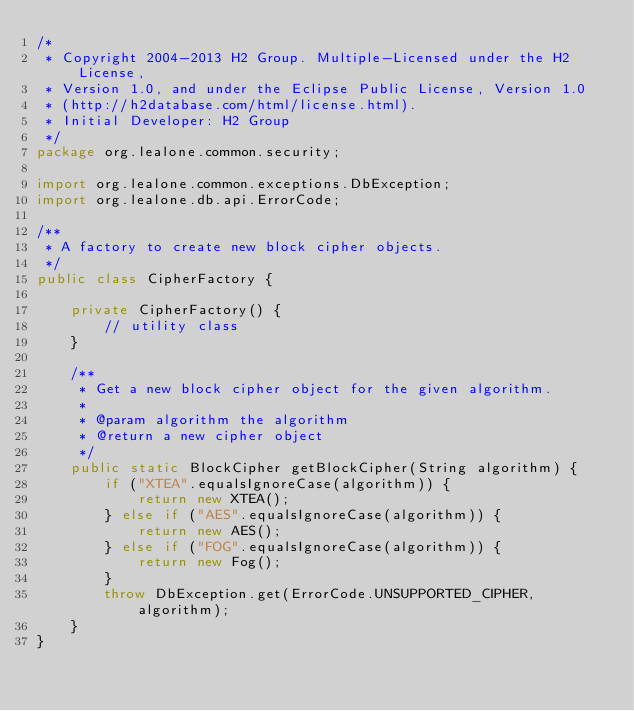<code> <loc_0><loc_0><loc_500><loc_500><_Java_>/*
 * Copyright 2004-2013 H2 Group. Multiple-Licensed under the H2 License,
 * Version 1.0, and under the Eclipse Public License, Version 1.0
 * (http://h2database.com/html/license.html).
 * Initial Developer: H2 Group
 */
package org.lealone.common.security;

import org.lealone.common.exceptions.DbException;
import org.lealone.db.api.ErrorCode;

/**
 * A factory to create new block cipher objects.
 */
public class CipherFactory {

    private CipherFactory() {
        // utility class
    }

    /**
     * Get a new block cipher object for the given algorithm.
     *
     * @param algorithm the algorithm
     * @return a new cipher object
     */
    public static BlockCipher getBlockCipher(String algorithm) {
        if ("XTEA".equalsIgnoreCase(algorithm)) {
            return new XTEA();
        } else if ("AES".equalsIgnoreCase(algorithm)) {
            return new AES();
        } else if ("FOG".equalsIgnoreCase(algorithm)) {
            return new Fog();
        }
        throw DbException.get(ErrorCode.UNSUPPORTED_CIPHER, algorithm);
    }
}
</code> 